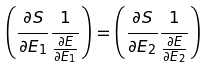Convert formula to latex. <formula><loc_0><loc_0><loc_500><loc_500>\left ( \frac { \partial S } { \partial E _ { 1 } } \frac { 1 } { \frac { \partial E } { \partial E _ { 1 } } } \right ) = \left ( \frac { \partial S } { \partial E _ { 2 } } \frac { 1 } { \frac { \partial E } { \partial E _ { 2 } } } \right )</formula> 